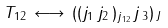Convert formula to latex. <formula><loc_0><loc_0><loc_500><loc_500>T _ { 1 2 } \, \longleftrightarrow \, ( ( j _ { 1 } \, j _ { 2 } \, ) _ { j _ { \, 1 2 } } j \, _ { 3 } ) _ { \, J }</formula> 